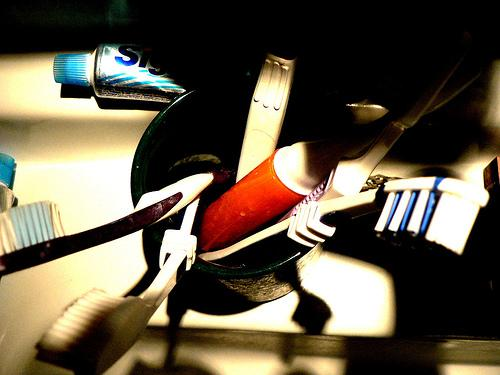List the main items displayed in the image. Green cup, toothbrushes, toothpaste tube, shadows from toothbrush and cup. Describe the image as if talking to a friend who cannot see it. Hey, so I'm looking at this picture of a bathroom counter with a green cup holding various toothbrushes and a blue and white tube of toothpaste. Also, there are some shadows from the toothbrush and cup. Create a captivating caption for the image. Toothbrush party: A colorful collection of dental guardians gathered in a green cup! State the main purpose and elements of the image in an insightful manner. The image conveys dental hygiene importance by showcasing a green cup filled with toothbrushes and a tube of toothpaste on the counter. Write a short summary of the image content using simple words. Cup holding toothbrushes, toothpaste tube, and shadows on counter. Provide a detailed description of the main objects in the image. There is a green cup with various toothbrushes, a blue and white toothpaste tube with blue cap, and shadows from the toothbrush and cup on the counter. Mention the primary focus of the image in a brief sentence. The image focuses on a green cup with toothbrushes and a toothpaste tube on the counter. Write a quick note describing the image for a fast reader. Green cup holding toothbrushes, blue and white toothpaste tube, and shadows on counter. Write a concise explanation of what can be found in the image. A green cup contains toothbrushes, and a toothpaste tube lies on the counter, with shadows visible from both. Describe the composition of the image in a short and precise way. The image contains a green cup with toothbrushes, a toothpaste tube, and shadows cast on the counter. Does the green cup have a pink handle? The green cup mentioned in the image does not have any handle, let alone a pink one, making this instruction incorrect and misleading. Is there a comb present in the toothbrush holder? No, it's not mentioned in the image. Is the toothpaste tube you see pink and yellow? The actual color of the toothpaste tube is blue and white, but this instruction asks about a pink and yellow toothpaste tube, which can be considered misleading. Aren't the toothbrushes all lying horizontally on the counter? The image has toothbrushes standing up in a mug, not lying horizontally on the counter, making this instruction misleading. Please find a toothbrush with black bristles in the image. There is no mention of a toothbrush with black bristles in the given image, making this instruction misleading. There are only two toothbrush handles visible in the picture. The image actually contains six toothbrush handles, making this instruction inaccurate and misleading. 